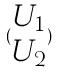Convert formula to latex. <formula><loc_0><loc_0><loc_500><loc_500>( \begin{matrix} U _ { 1 } \\ U _ { 2 } \end{matrix} )</formula> 